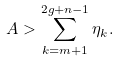Convert formula to latex. <formula><loc_0><loc_0><loc_500><loc_500>A > \sum _ { k = m + 1 } ^ { 2 g + n - 1 } \eta _ { k } .</formula> 